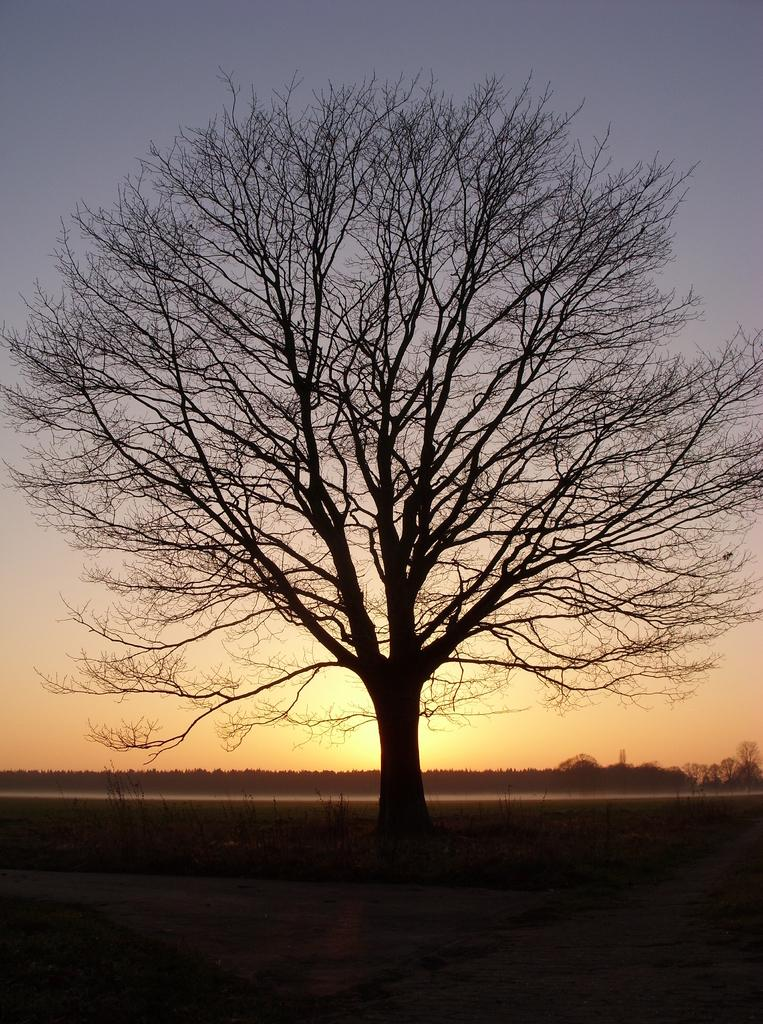What type of setting is depicted in the image? The image is an outside view. What specific object can be seen in the image? There is a tree in the image. How many trees are visible in the background of the image? There are many trees in the background of the image. What is visible at the top of the image? The sky is visible at the top of the image. Can you see an owl reading a book in the tree? There is no owl or book present in the image; it only features a tree and the surrounding environment. 